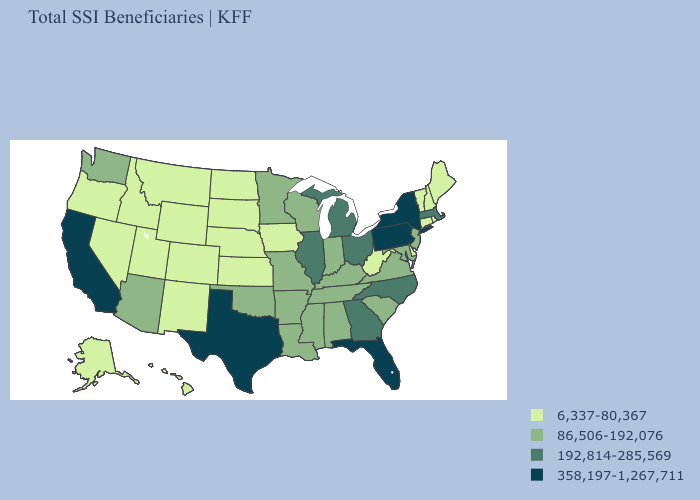What is the lowest value in the Northeast?
Keep it brief. 6,337-80,367. Does Hawaii have the highest value in the USA?
Give a very brief answer. No. Among the states that border Arizona , which have the highest value?
Concise answer only. California. What is the highest value in states that border Kansas?
Short answer required. 86,506-192,076. What is the value of Massachusetts?
Concise answer only. 192,814-285,569. Among the states that border Rhode Island , which have the lowest value?
Quick response, please. Connecticut. Among the states that border Washington , which have the lowest value?
Keep it brief. Idaho, Oregon. What is the value of Massachusetts?
Short answer required. 192,814-285,569. What is the value of New Jersey?
Concise answer only. 86,506-192,076. Does California have the lowest value in the West?
Concise answer only. No. What is the value of Oklahoma?
Concise answer only. 86,506-192,076. How many symbols are there in the legend?
Concise answer only. 4. Which states have the lowest value in the Northeast?
Keep it brief. Connecticut, Maine, New Hampshire, Rhode Island, Vermont. What is the value of Tennessee?
Keep it brief. 86,506-192,076. Among the states that border California , does Oregon have the lowest value?
Write a very short answer. Yes. 